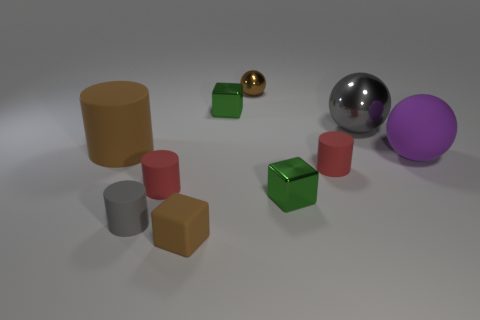Are there more big matte balls that are to the left of the big gray ball than rubber spheres in front of the gray matte thing?
Ensure brevity in your answer.  No. Does the large shiny ball have the same color as the large matte thing on the right side of the big gray shiny ball?
Make the answer very short. No. What is the material of the purple object that is the same size as the gray sphere?
Offer a terse response. Rubber. How many objects are either brown matte blocks or metallic things in front of the tiny brown metallic object?
Your response must be concise. 4. Does the purple matte ball have the same size as the rubber thing that is left of the gray cylinder?
Offer a very short reply. Yes. What number of spheres are either brown matte things or small metal things?
Provide a succinct answer. 1. How many things are both to the right of the tiny brown metal thing and behind the big matte sphere?
Your answer should be very brief. 1. What number of other things are there of the same color as the matte sphere?
Make the answer very short. 0. What shape is the small red matte thing that is left of the small brown rubber block?
Keep it short and to the point. Cylinder. Are the big cylinder and the purple ball made of the same material?
Your answer should be very brief. Yes. 